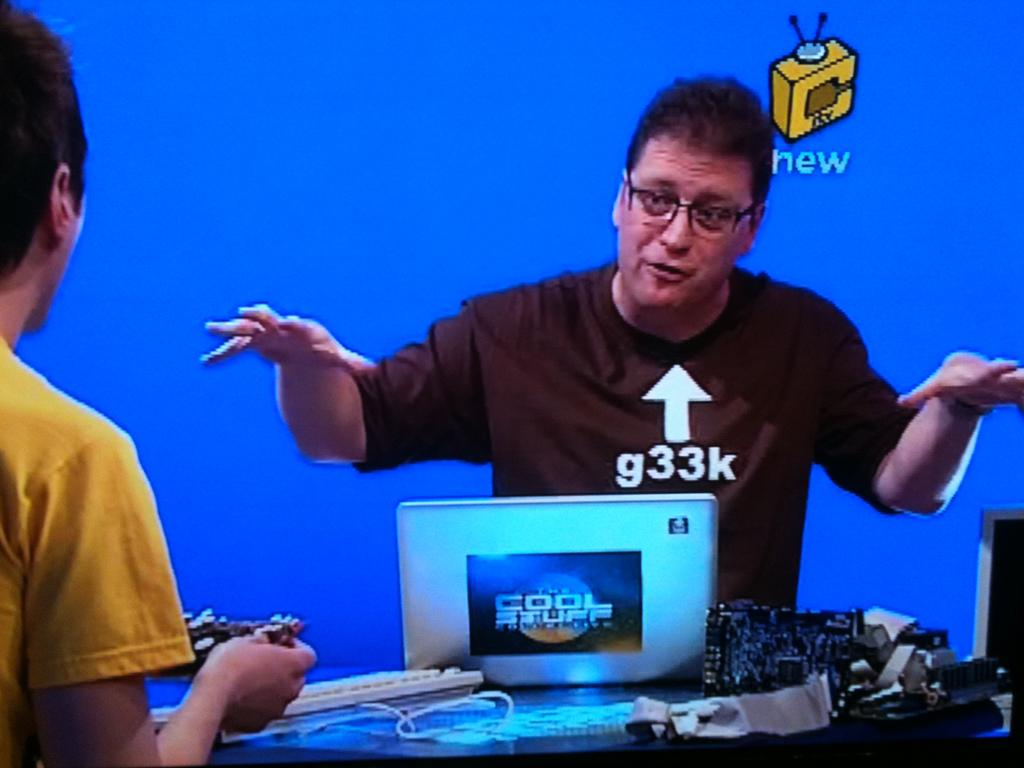<image>
Present a compact description of the photo's key features. A man with the words g33k pointing at him talks to someone holding a video game controller. 